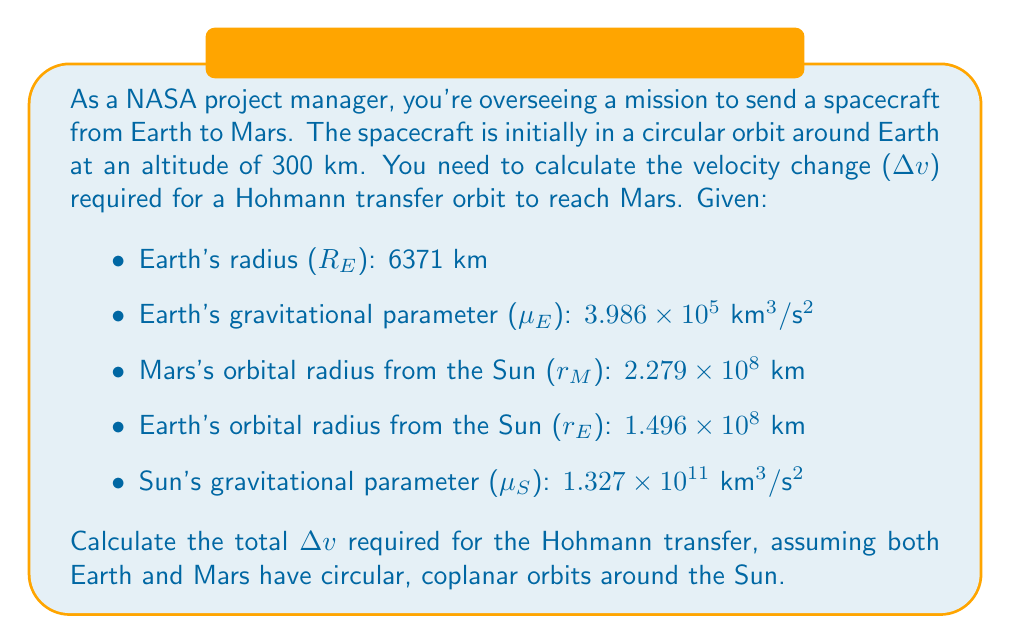Can you answer this question? To solve this problem, we'll use the principles of orbital mechanics and vector geometry. We'll break it down into steps:

1. Calculate the velocity of the spacecraft in its initial Earth orbit:

The radius of the initial orbit is:
$$ r_1 = R_E + 300 \text{ km} = 6671 \text{ km} $$

The velocity in a circular orbit is given by:
$$ v_1 = \sqrt{\frac{\mu_E}{r_1}} = \sqrt{\frac{3.986 \times 10^5}{6671}} = 7.726 \text{ km/s} $$

2. Calculate the velocity at periapsis of the Hohmann transfer orbit around Earth:

The semi-major axis of the transfer orbit is:
$$ a_t = \frac{r_E + r_M}{2} = \frac{1.496 \times 10^8 + 2.279 \times 10^8}{2} = 1.8875 \times 10^8 \text{ km} $$

The velocity at periapsis of the transfer orbit is:
$$ v_p = \sqrt{\mu_S \left(\frac{2}{r_E} - \frac{1}{a_t}\right)} = \sqrt{1.327 \times 10^{11} \left(\frac{2}{1.496 \times 10^8} - \frac{1}{1.8875 \times 10^8}\right)} = 32.73 \text{ km/s} $$

3. Calculate the Δv required for the first burn (from Earth orbit to transfer orbit):

$$ \Delta v_1 = v_p - v_1 = 32.73 - 7.726 = 25.004 \text{ km/s} $$

4. Calculate the velocity at apoapsis of the transfer orbit (at Mars's distance):

$$ v_a = \sqrt{\mu_S \left(\frac{2}{r_M} - \frac{1}{a_t}\right)} = \sqrt{1.327 \times 10^{11} \left(\frac{2}{2.279 \times 10^8} - \frac{1}{1.8875 \times 10^8}\right)} = 21.48 \text{ km/s} $$

5. Calculate Mars's orbital velocity:

$$ v_M = \sqrt{\frac{\mu_S}{r_M}} = \sqrt{\frac{1.327 \times 10^{11}}{2.279 \times 10^8}} = 24.13 \text{ km/s} $$

6. Calculate the Δv required for the second burn (to match Mars's orbit):

$$ \Delta v_2 = v_M - v_a = 24.13 - 21.48 = 2.65 \text{ km/s} $$

7. Calculate the total Δv required:

$$ \Delta v_{\text{total}} = \Delta v_1 + \Delta v_2 = 25.004 + 2.65 = 27.654 \text{ km/s} $$

This total Δv represents the minimum velocity change required for a Hohmann transfer from the given Earth orbit to Mars's orbit, assuming both planets have circular, coplanar orbits around the Sun.
Answer: The total Δv required for the Hohmann transfer from Earth orbit to Mars orbit is approximately 27.654 km/s. 